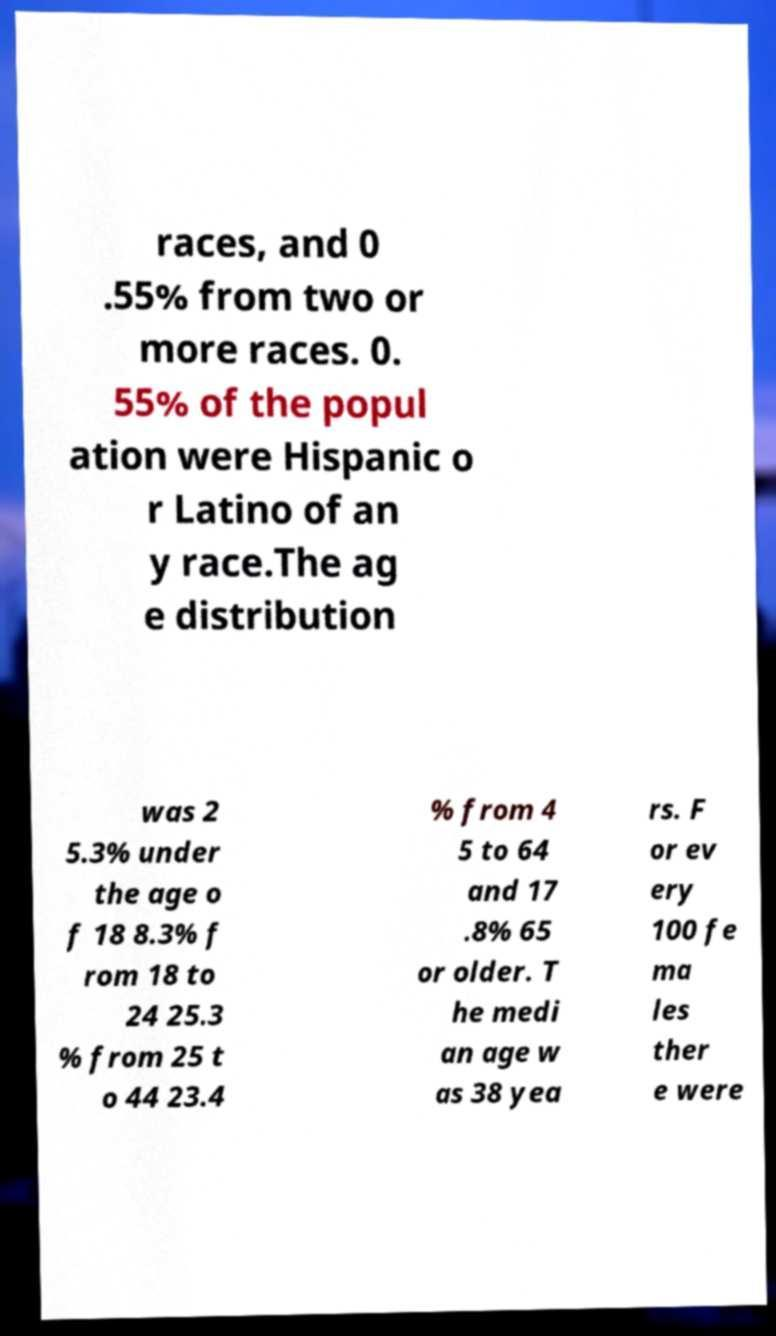Can you accurately transcribe the text from the provided image for me? races, and 0 .55% from two or more races. 0. 55% of the popul ation were Hispanic o r Latino of an y race.The ag e distribution was 2 5.3% under the age o f 18 8.3% f rom 18 to 24 25.3 % from 25 t o 44 23.4 % from 4 5 to 64 and 17 .8% 65 or older. T he medi an age w as 38 yea rs. F or ev ery 100 fe ma les ther e were 